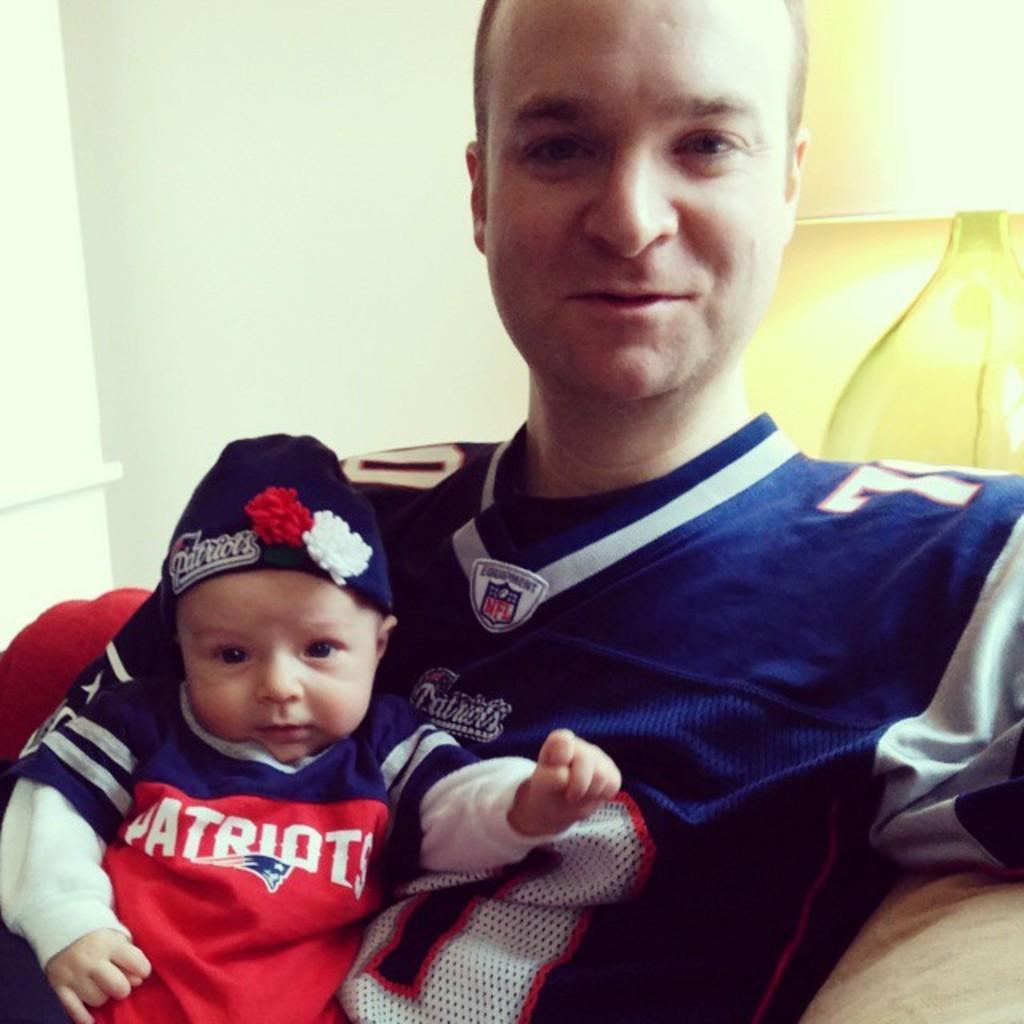<image>
Render a clear and concise summary of the photo. a person that has Patriots on their shirt posing with their dad 